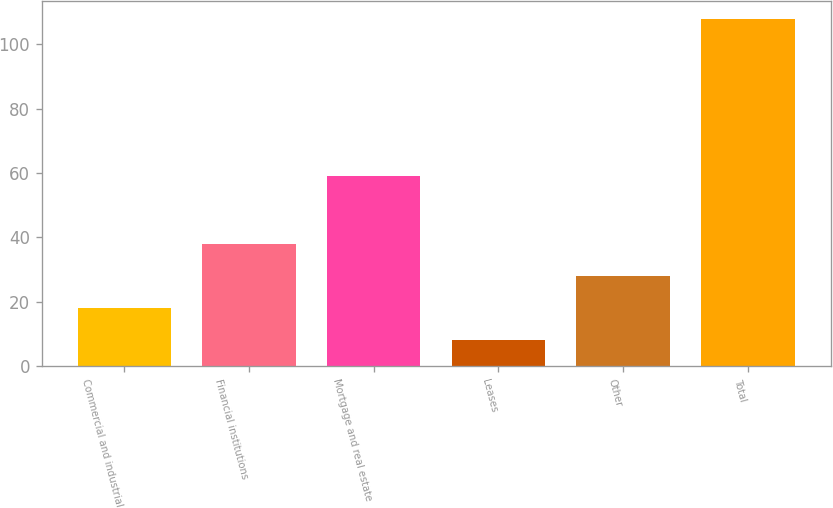Convert chart to OTSL. <chart><loc_0><loc_0><loc_500><loc_500><bar_chart><fcel>Commercial and industrial<fcel>Financial institutions<fcel>Mortgage and real estate<fcel>Leases<fcel>Other<fcel>Total<nl><fcel>18<fcel>38<fcel>59<fcel>8<fcel>28<fcel>108<nl></chart> 